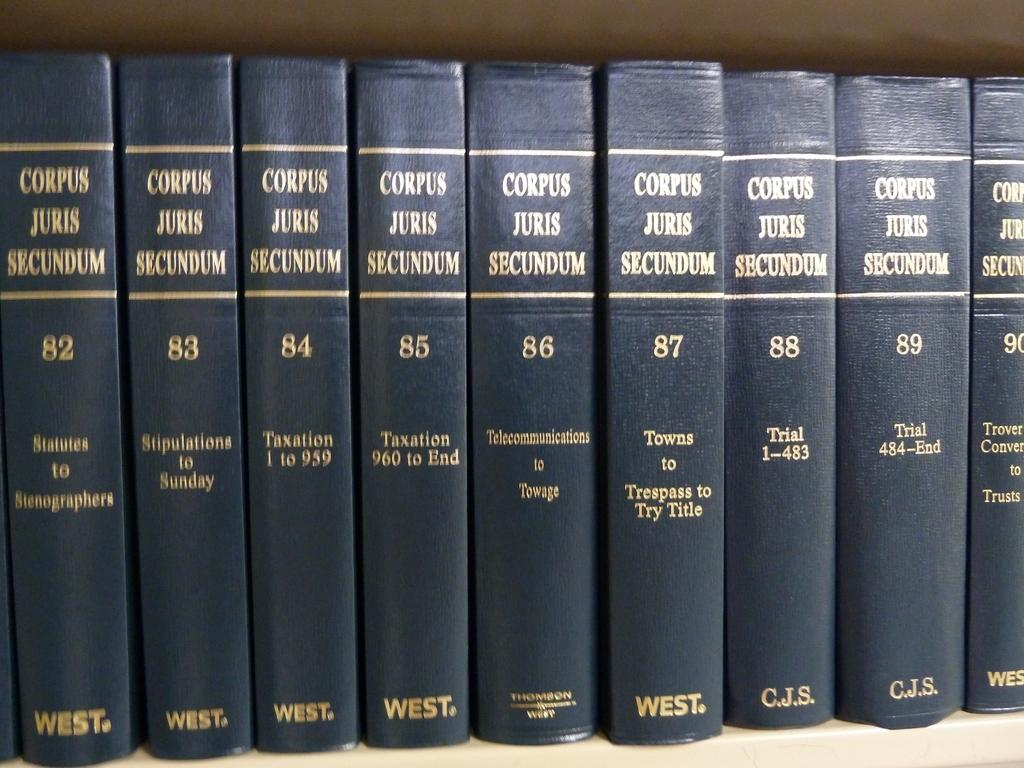<image>
Present a compact description of the photo's key features. A series of books Corpus Juris Secundum, is in order by volume. 